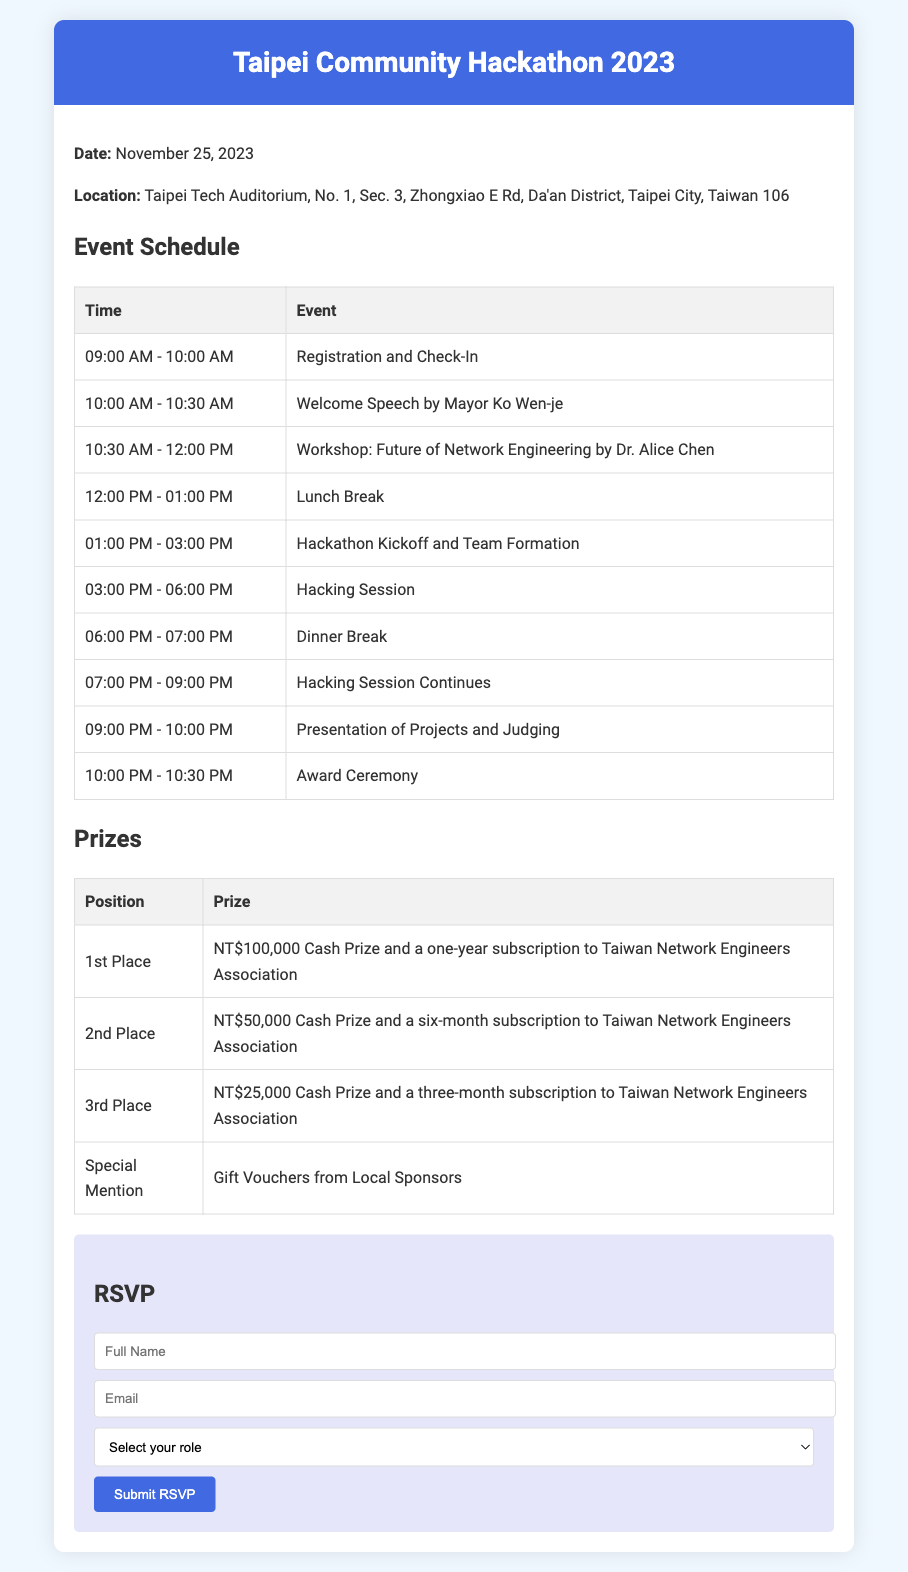What is the date of the hackathon? The date of the hackathon is mentioned in the document.
Answer: November 25, 2023 Where is the hackathon taking place? The location of the hackathon is provided in the document.
Answer: Taipei Tech Auditorium Who is giving the welcome speech? The name of the speaker for the welcome speech is listed in the schedule.
Answer: Mayor Ko Wen-je What is the prize for the 1st place winner? The document specifies the prize for the 1st place position.
Answer: NT$100,000 Cash Prize and a one-year subscription to Taiwan Network Engineers Association What time does the registration start? The schedule indicates the time for registration and check-in.
Answer: 09:00 AM How many awards are mentioned in the prizes section? The document lists specific awards, indicating the positions that receive prizes.
Answer: Four What role can participants select in the RSVP? The RSVP form includes specific role options for participants.
Answer: Participant What time does the award ceremony begin? The schedule provides the time for the award ceremony.
Answer: 10:00 PM What is required to submit the RSVP? The document outlines the necessary fields to complete for the RSVP submission.
Answer: Full Name, Email, and Role selection 